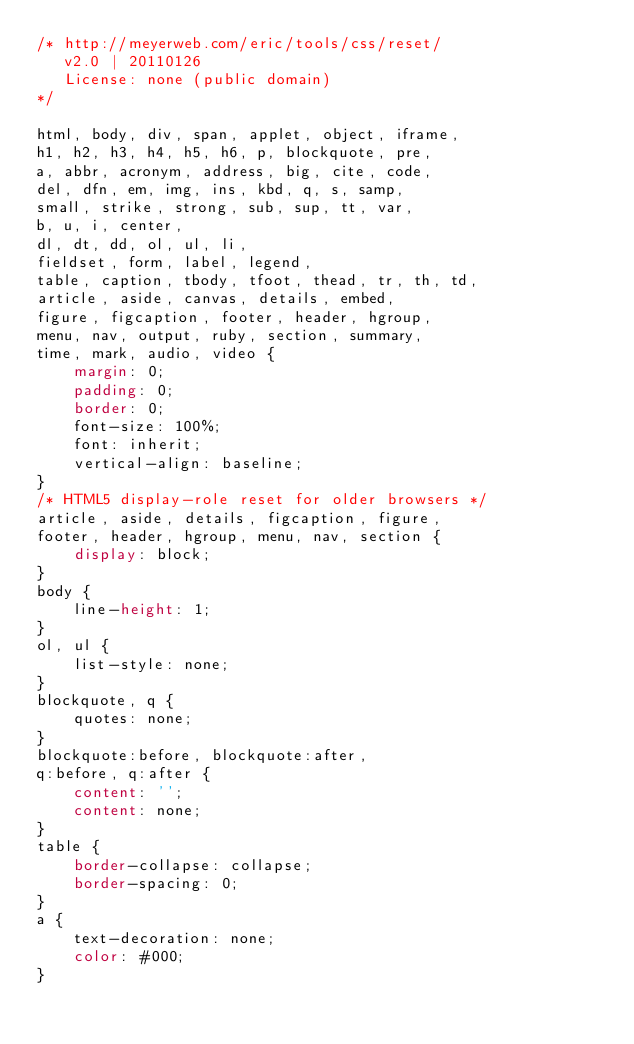Convert code to text. <code><loc_0><loc_0><loc_500><loc_500><_CSS_>/* http://meyerweb.com/eric/tools/css/reset/
   v2.0 | 20110126
   License: none (public domain)
*/

html, body, div, span, applet, object, iframe,
h1, h2, h3, h4, h5, h6, p, blockquote, pre,
a, abbr, acronym, address, big, cite, code,
del, dfn, em, img, ins, kbd, q, s, samp,
small, strike, strong, sub, sup, tt, var,
b, u, i, center,
dl, dt, dd, ol, ul, li,
fieldset, form, label, legend,
table, caption, tbody, tfoot, thead, tr, th, td,
article, aside, canvas, details, embed,
figure, figcaption, footer, header, hgroup,
menu, nav, output, ruby, section, summary,
time, mark, audio, video {
	margin: 0;
	padding: 0;
	border: 0;
	font-size: 100%;
	font: inherit;
	vertical-align: baseline;
}
/* HTML5 display-role reset for older browsers */
article, aside, details, figcaption, figure,
footer, header, hgroup, menu, nav, section {
	display: block;
}
body {
	line-height: 1;
}
ol, ul {
	list-style: none;
}
blockquote, q {
	quotes: none;
}
blockquote:before, blockquote:after,
q:before, q:after {
	content: '';
	content: none;
}
table {
	border-collapse: collapse;
	border-spacing: 0;
}
a {
    text-decoration: none;
    color: #000;
}
</code> 